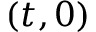<formula> <loc_0><loc_0><loc_500><loc_500>( t , 0 )</formula> 